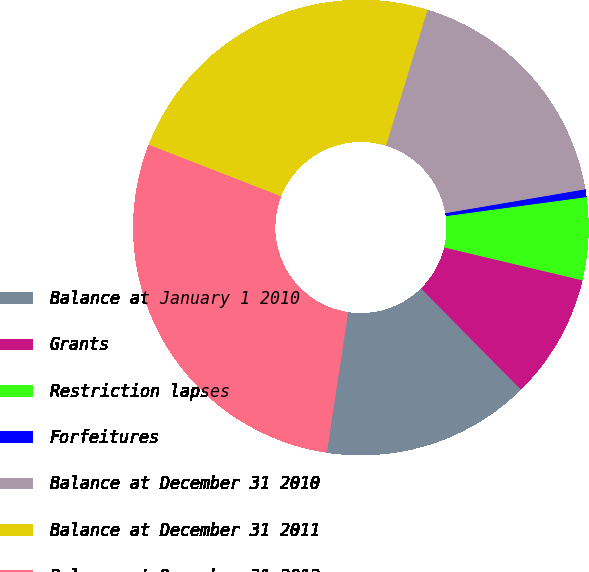Convert chart. <chart><loc_0><loc_0><loc_500><loc_500><pie_chart><fcel>Balance at January 1 2010<fcel>Grants<fcel>Restriction lapses<fcel>Forfeitures<fcel>Balance at December 31 2010<fcel>Balance at December 31 2011<fcel>Balance at December 31 2012<nl><fcel>14.8%<fcel>8.88%<fcel>5.86%<fcel>0.55%<fcel>17.59%<fcel>23.81%<fcel>28.52%<nl></chart> 